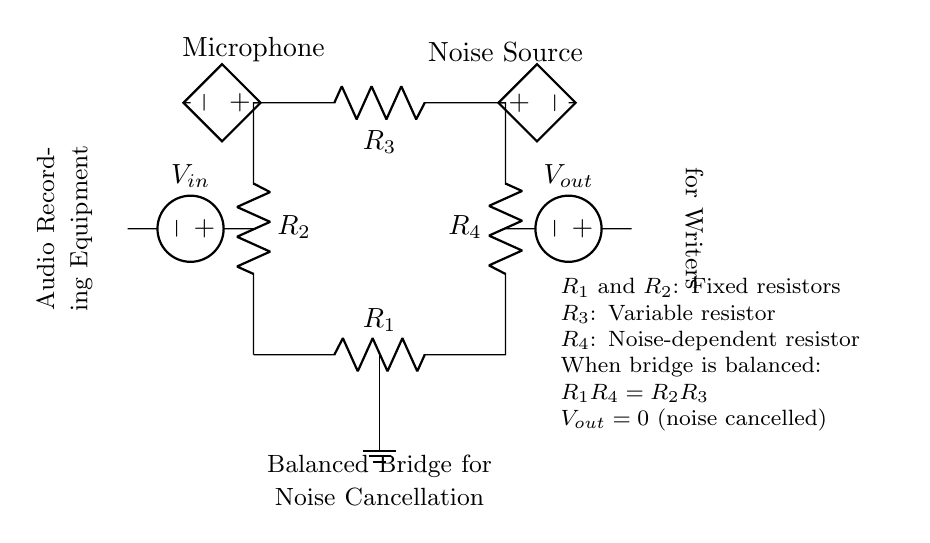What are the types of resistors in this circuit? The circuit includes two fixed resistors, one variable resistor, and one noise-dependent resistor. Specifically, R1 and R2 are fixed, R3 is variable, and R4 is noise-dependent.
Answer: Fixed, variable, noise-dependent What is the purpose of the noise-dependent resistor? The noise-dependent resistor (R4) adjusts its value based on the noise level in the environment, which helps to balance the bridge circuit and cancel out unwanted noise.
Answer: Noise cancellation What condition must be met for the output voltage to be zero? For the output voltage (Vout) to be zero, the relationship R1R4 must equal R2R3, which indicates that the bridge is in a balanced state, effectively cancelling noise.
Answer: R1R4 = R2R3 What components are connected to the microphone? The microphone connects to a controlled voltage source, which represents the audio signal being processed in the circuit.
Answer: Controlled voltage source What label indicates the balance purpose of this bridge? The label "Balanced Bridge for Noise Cancellation" indicates the primary function of the circuit, emphasizing its design for cancelling noise in audio recording equipment.
Answer: Balanced Bridge for Noise Cancellation How is the circuit powered? The circuit is powered by the voltage sources connected at the input (Vin) and output (Vout), providing the necessary potential differences for operation.
Answer: Voltage sources 